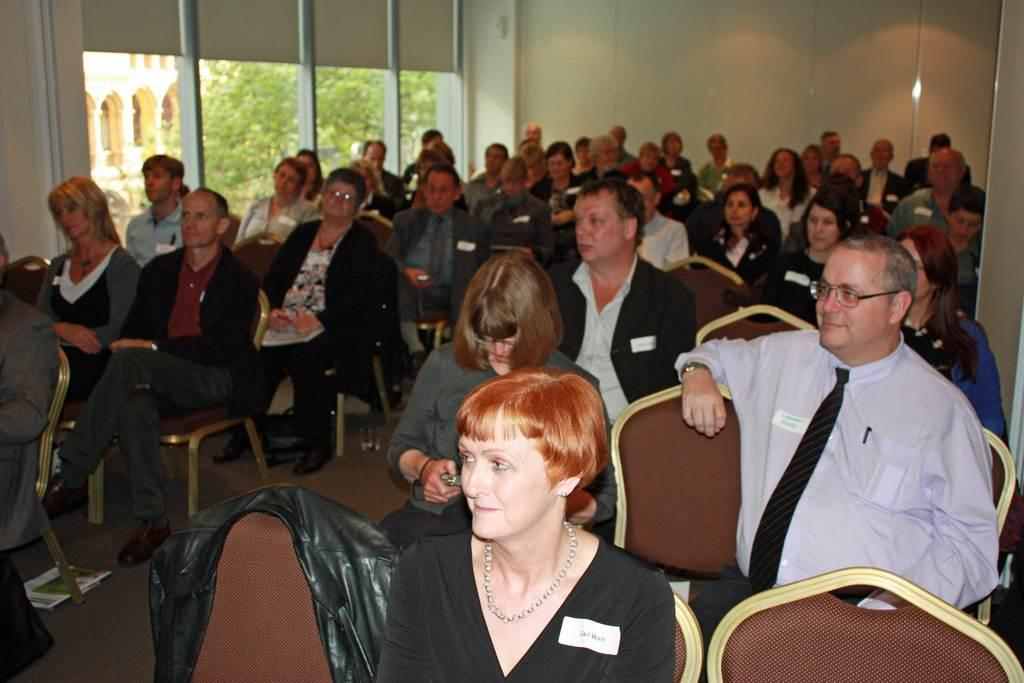What are the people in the image doing? The persons in the image are sitting on chairs. What can be seen on the ground in the image? The floor is visible in the image. What is visible on the wall in the image? The wall is visible in the image. What can be seen through the glass in the image? There is a tree and a building visible from the glass. What type of prose is being written by the persons sitting on chairs in the image? There is no indication in the image that the persons sitting on chairs are writing any prose. 